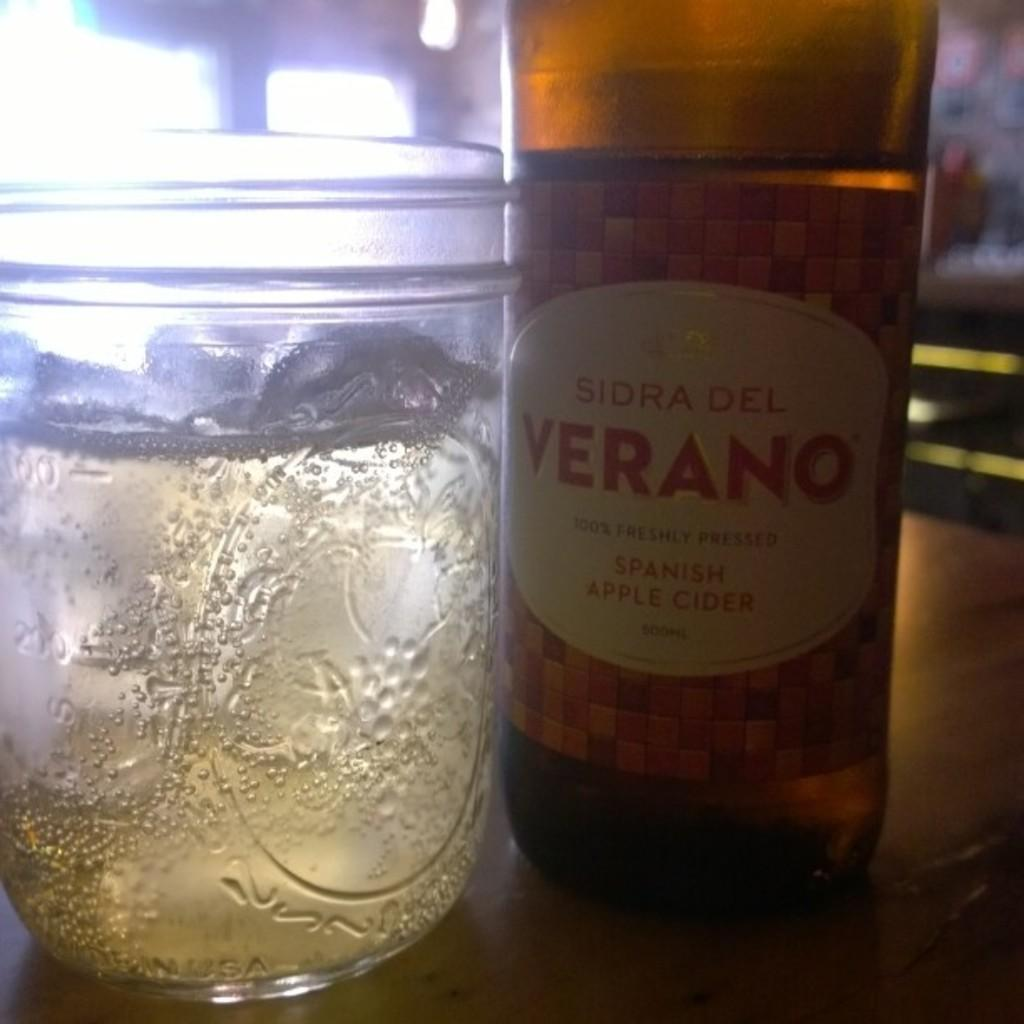<image>
Provide a brief description of the given image. A glass sitting next to a bottle of Spanish Apple Cider. 